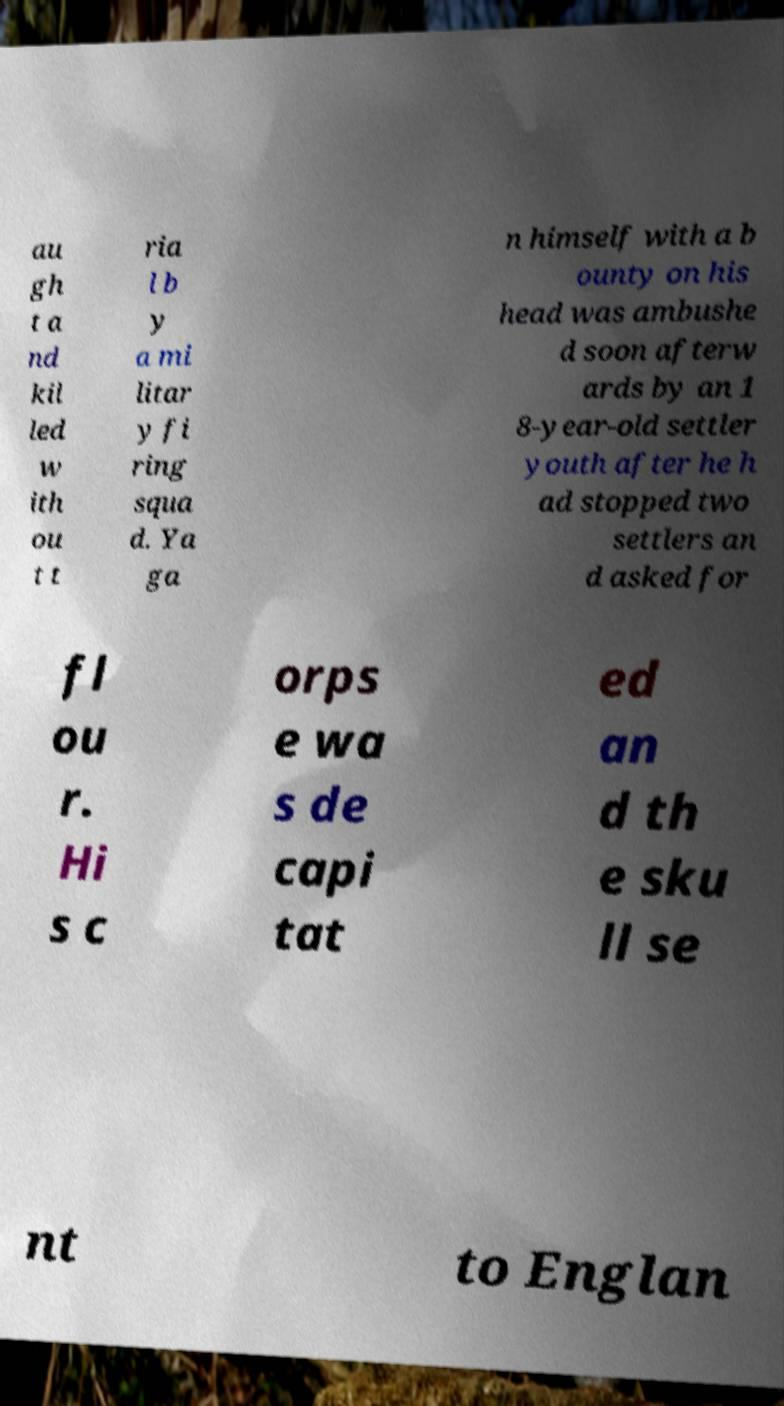Could you assist in decoding the text presented in this image and type it out clearly? au gh t a nd kil led w ith ou t t ria l b y a mi litar y fi ring squa d. Ya ga n himself with a b ounty on his head was ambushe d soon afterw ards by an 1 8-year-old settler youth after he h ad stopped two settlers an d asked for fl ou r. Hi s c orps e wa s de capi tat ed an d th e sku ll se nt to Englan 